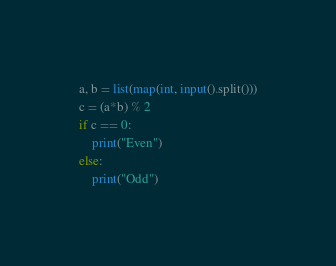Convert code to text. <code><loc_0><loc_0><loc_500><loc_500><_Python_>a, b = list(map(int, input().split()))
c = (a*b) % 2
if c == 0:
	print("Even")
else:
	print("Odd")</code> 